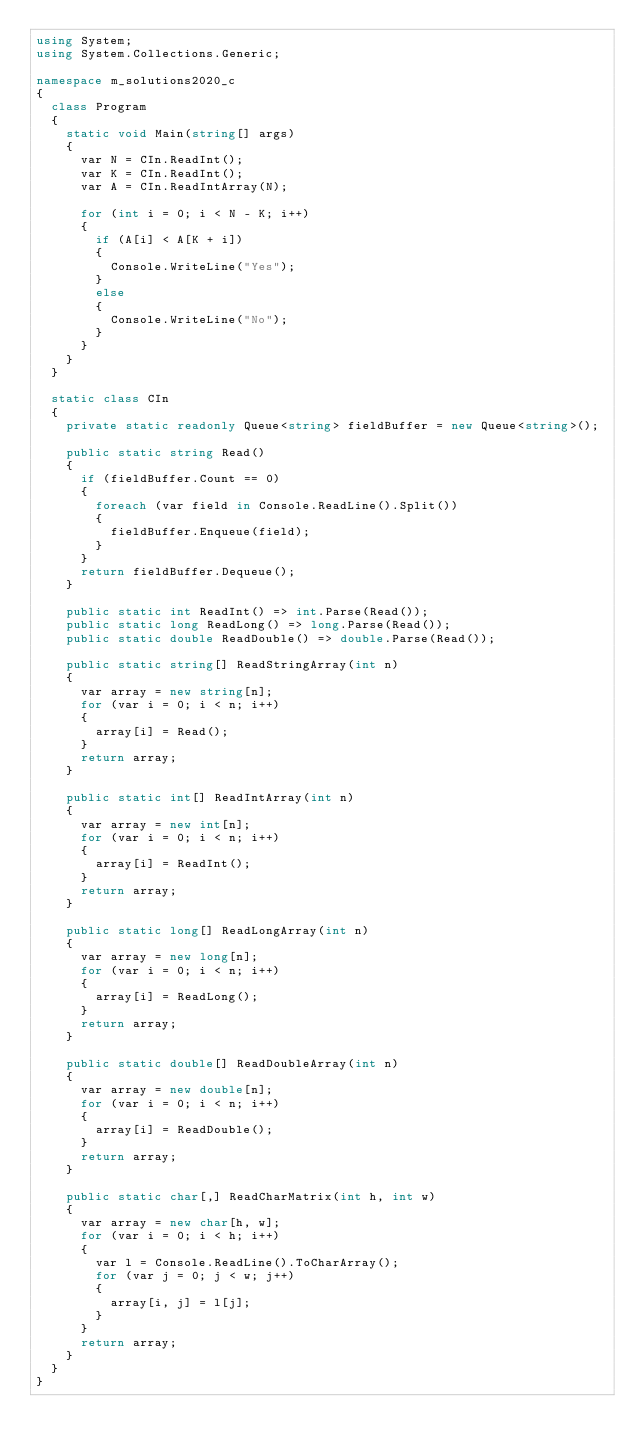<code> <loc_0><loc_0><loc_500><loc_500><_C#_>using System;
using System.Collections.Generic;

namespace m_solutions2020_c
{
  class Program
  {
    static void Main(string[] args)
    {
      var N = CIn.ReadInt();
      var K = CIn.ReadInt();
      var A = CIn.ReadIntArray(N);

      for (int i = 0; i < N - K; i++)
      {
        if (A[i] < A[K + i])
        {
          Console.WriteLine("Yes");
        }
        else
        {
          Console.WriteLine("No");
        }
      }
    }
  }

  static class CIn
  {
    private static readonly Queue<string> fieldBuffer = new Queue<string>();

    public static string Read()
    {
      if (fieldBuffer.Count == 0)
      {
        foreach (var field in Console.ReadLine().Split())
        {
          fieldBuffer.Enqueue(field);
        }
      }
      return fieldBuffer.Dequeue();
    }

    public static int ReadInt() => int.Parse(Read());
    public static long ReadLong() => long.Parse(Read());
    public static double ReadDouble() => double.Parse(Read());

    public static string[] ReadStringArray(int n)
    {
      var array = new string[n];
      for (var i = 0; i < n; i++)
      {
        array[i] = Read();
      }
      return array;
    }

    public static int[] ReadIntArray(int n)
    {
      var array = new int[n];
      for (var i = 0; i < n; i++)
      {
        array[i] = ReadInt();
      }
      return array;
    }

    public static long[] ReadLongArray(int n)
    {
      var array = new long[n];
      for (var i = 0; i < n; i++)
      {
        array[i] = ReadLong();
      }
      return array;
    }

    public static double[] ReadDoubleArray(int n)
    {
      var array = new double[n];
      for (var i = 0; i < n; i++)
      {
        array[i] = ReadDouble();
      }
      return array;
    }

    public static char[,] ReadCharMatrix(int h, int w)
    {
      var array = new char[h, w];
      for (var i = 0; i < h; i++)
      {
        var l = Console.ReadLine().ToCharArray();
        for (var j = 0; j < w; j++)
        {
          array[i, j] = l[j];
        }
      }
      return array;
    }
  }
}
</code> 